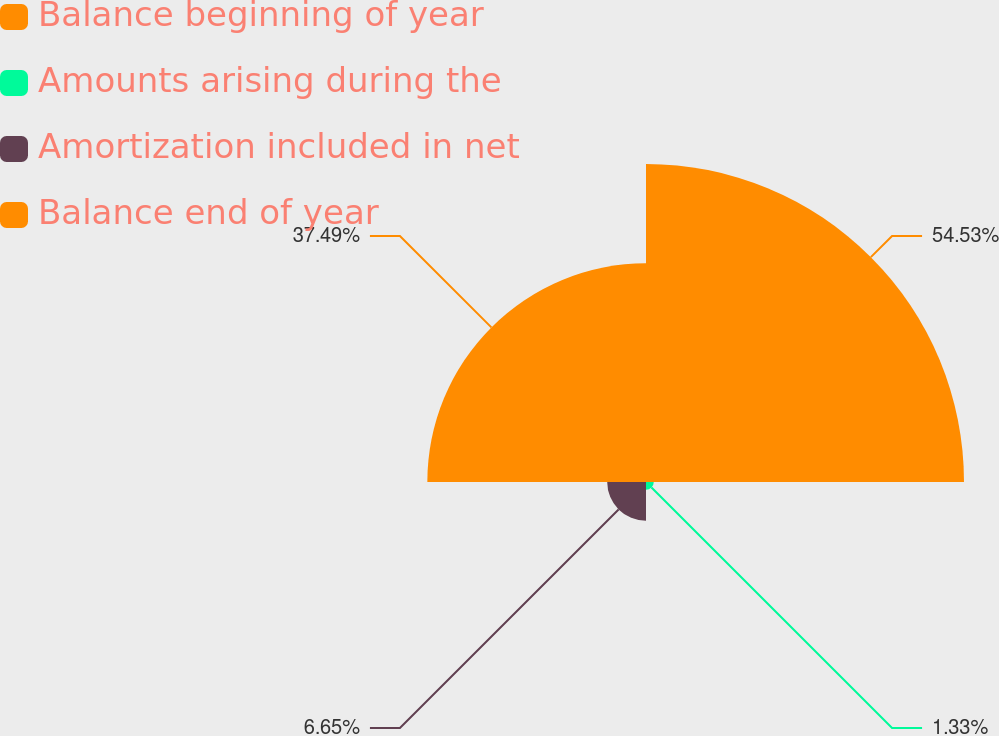Convert chart. <chart><loc_0><loc_0><loc_500><loc_500><pie_chart><fcel>Balance beginning of year<fcel>Amounts arising during the<fcel>Amortization included in net<fcel>Balance end of year<nl><fcel>54.52%<fcel>1.33%<fcel>6.65%<fcel>37.49%<nl></chart> 